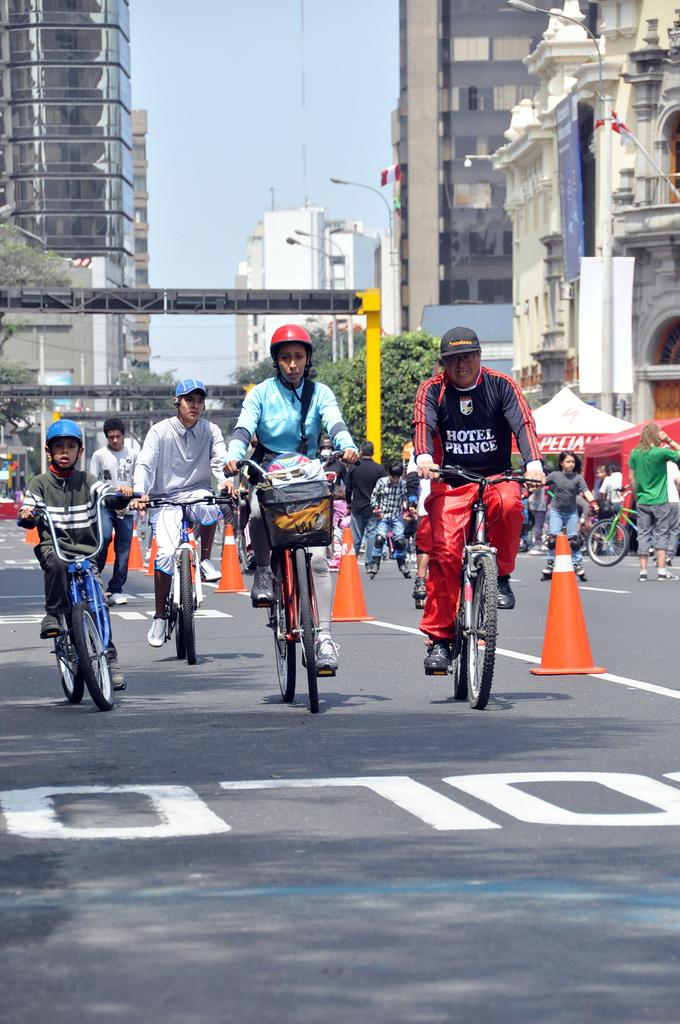How many people are riding the bicycle in the image? There are four people riding the bicycle in the image. Where is the bicycle located? The bicycle is on the road. What can be seen in the background of the image? There are buildings in the background. Are there any other people visible in the image? Yes, there are a few people on the right side in the background. What type of approval is required for the visitors to wash the bicycle in the image? There are no visitors or washing activities present in the image; it features four people riding a bicycle on the road. 